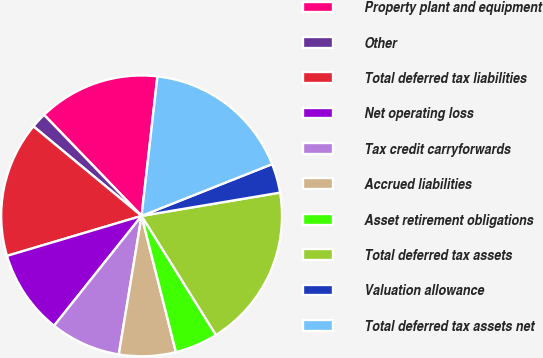Convert chart to OTSL. <chart><loc_0><loc_0><loc_500><loc_500><pie_chart><fcel>Property plant and equipment<fcel>Other<fcel>Total deferred tax liabilities<fcel>Net operating loss<fcel>Tax credit carryforwards<fcel>Accrued liabilities<fcel>Asset retirement obligations<fcel>Total deferred tax assets<fcel>Valuation allowance<fcel>Total deferred tax assets net<nl><fcel>14.02%<fcel>1.78%<fcel>15.6%<fcel>9.7%<fcel>8.11%<fcel>6.53%<fcel>4.95%<fcel>18.77%<fcel>3.36%<fcel>17.19%<nl></chart> 